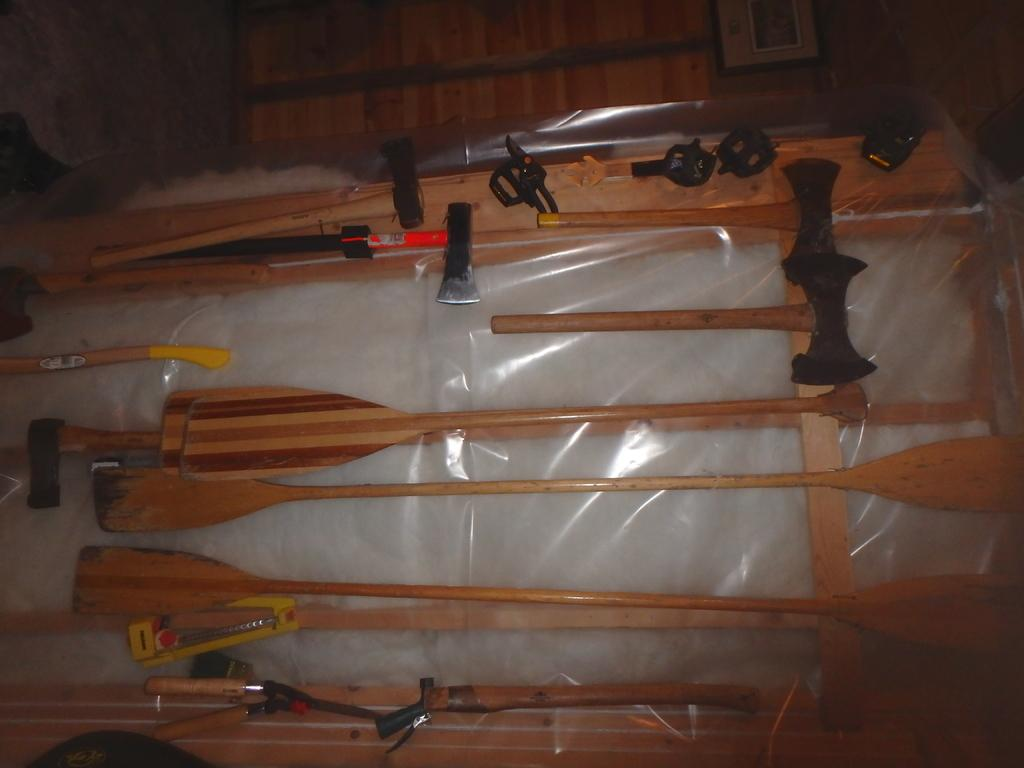What type of objects can be seen in the image related to rowing? There are rowing sticks in the image. What other objects are present in the image? There are cutters and an ace in the image. What material are the objects made of? The objects are made of metal, which is covered. What type of wall is visible in the image? There is a wooden wall in the image. Is there any decoration or structure on the wooden wall? Yes, there is a frame on the wooden wall. What type of leather material can be seen on the roof in the image? There is no roof present in the image, and therefore no leather material can be observed. 